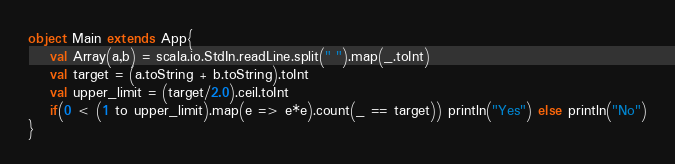Convert code to text. <code><loc_0><loc_0><loc_500><loc_500><_Scala_>object Main extends App{
    val Array(a,b) = scala.io.StdIn.readLine.split(" ").map(_.toInt)
    val target = (a.toString + b.toString).toInt
    val upper_limit = (target/2.0).ceil.toInt
    if(0 < (1 to upper_limit).map(e => e*e).count(_ == target)) println("Yes") else println("No")
}</code> 